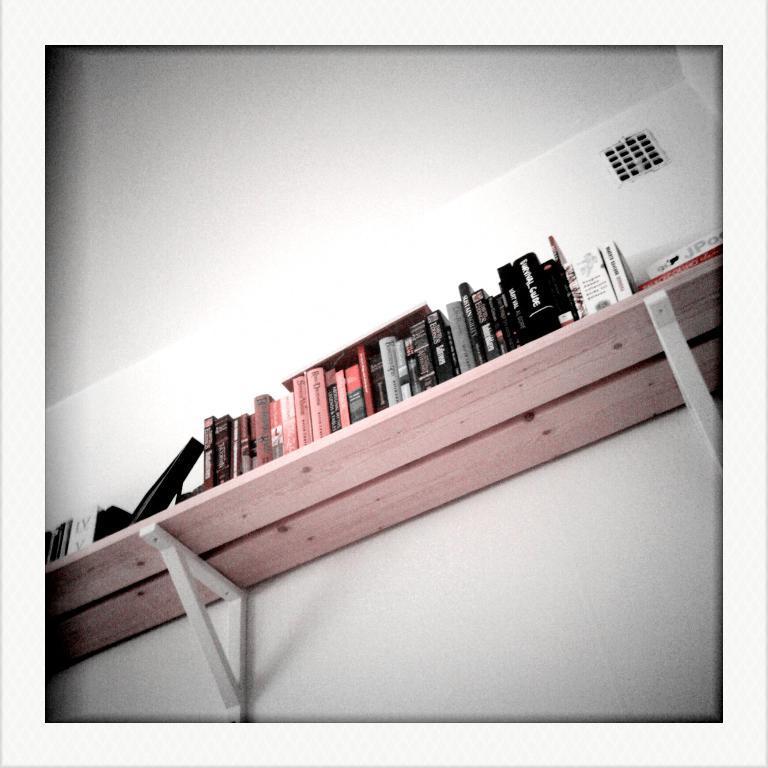Could you give a brief overview of what you see in this image? This picture seems to be clicked inside the room. In the center we can see the wooden rack on the top of which books and some other objects are placed and we can see the text on the covers of the books. At the top we can see the roof. In the background we can see the wall and an object seems to be the window. 